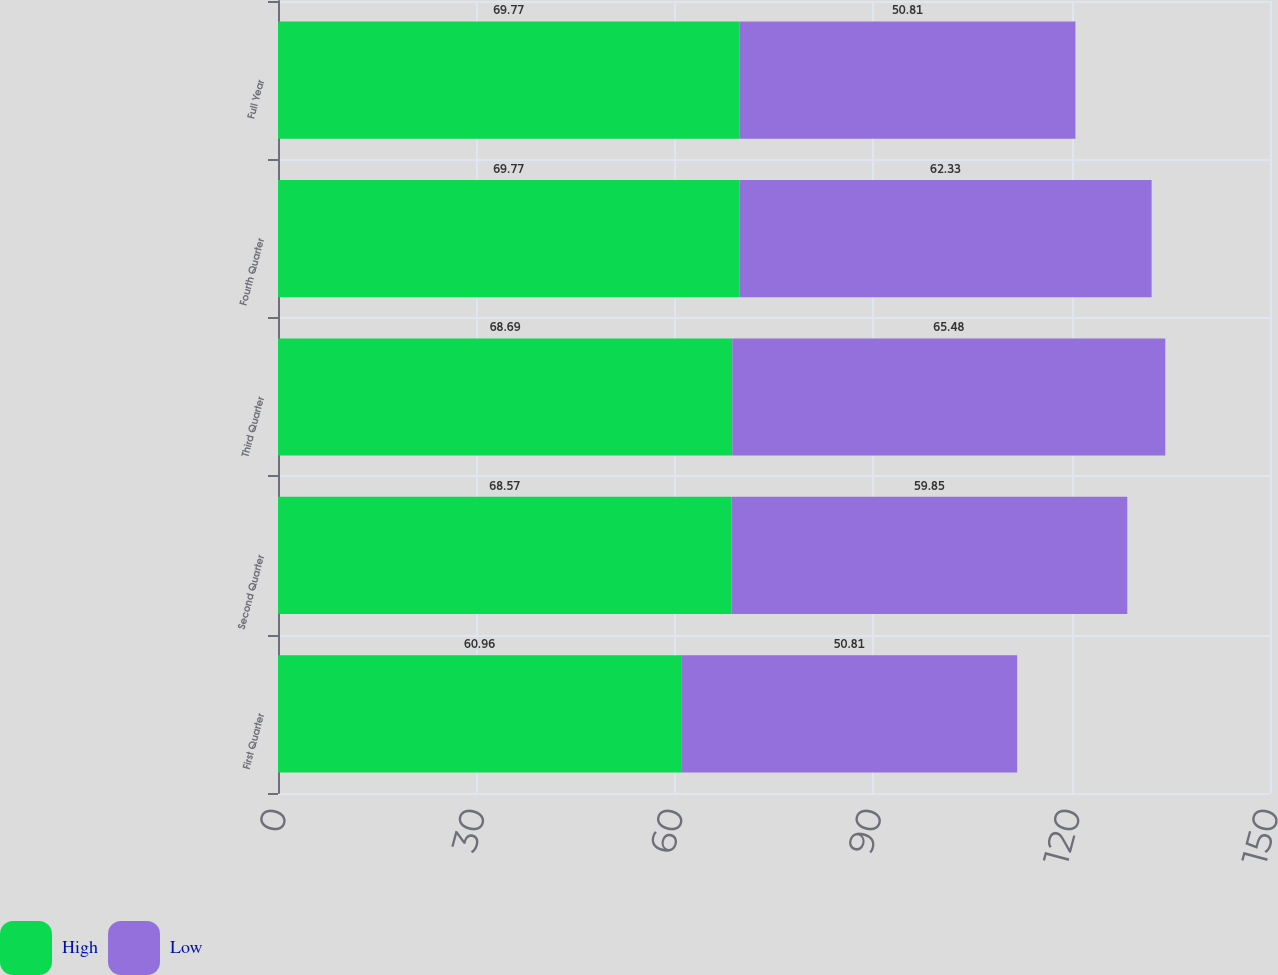<chart> <loc_0><loc_0><loc_500><loc_500><stacked_bar_chart><ecel><fcel>First Quarter<fcel>Second Quarter<fcel>Third Quarter<fcel>Fourth Quarter<fcel>Full Year<nl><fcel>High<fcel>60.96<fcel>68.57<fcel>68.69<fcel>69.77<fcel>69.77<nl><fcel>Low<fcel>50.81<fcel>59.85<fcel>65.48<fcel>62.33<fcel>50.81<nl></chart> 